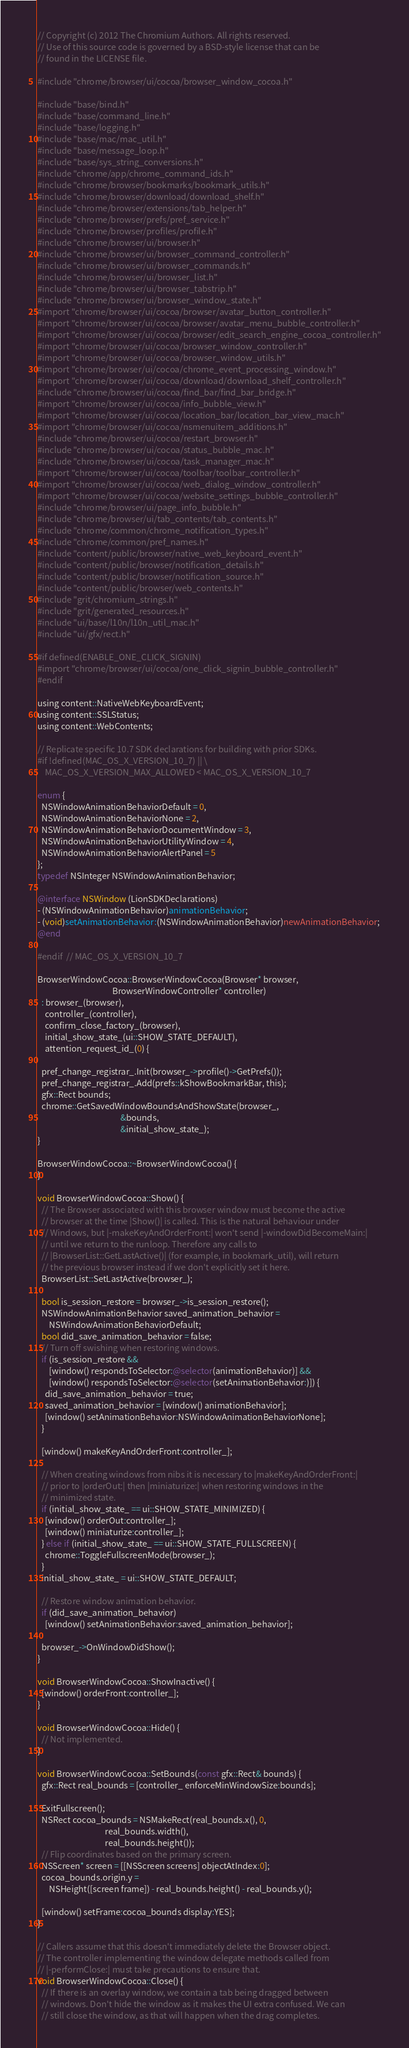Convert code to text. <code><loc_0><loc_0><loc_500><loc_500><_ObjectiveC_>// Copyright (c) 2012 The Chromium Authors. All rights reserved.
// Use of this source code is governed by a BSD-style license that can be
// found in the LICENSE file.

#include "chrome/browser/ui/cocoa/browser_window_cocoa.h"

#include "base/bind.h"
#include "base/command_line.h"
#include "base/logging.h"
#include "base/mac/mac_util.h"
#include "base/message_loop.h"
#include "base/sys_string_conversions.h"
#include "chrome/app/chrome_command_ids.h"
#include "chrome/browser/bookmarks/bookmark_utils.h"
#include "chrome/browser/download/download_shelf.h"
#include "chrome/browser/extensions/tab_helper.h"
#include "chrome/browser/prefs/pref_service.h"
#include "chrome/browser/profiles/profile.h"
#include "chrome/browser/ui/browser.h"
#include "chrome/browser/ui/browser_command_controller.h"
#include "chrome/browser/ui/browser_commands.h"
#include "chrome/browser/ui/browser_list.h"
#include "chrome/browser/ui/browser_tabstrip.h"
#include "chrome/browser/ui/browser_window_state.h"
#import "chrome/browser/ui/cocoa/browser/avatar_button_controller.h"
#import "chrome/browser/ui/cocoa/browser/avatar_menu_bubble_controller.h"
#import "chrome/browser/ui/cocoa/browser/edit_search_engine_cocoa_controller.h"
#import "chrome/browser/ui/cocoa/browser_window_controller.h"
#import "chrome/browser/ui/cocoa/browser_window_utils.h"
#import "chrome/browser/ui/cocoa/chrome_event_processing_window.h"
#import "chrome/browser/ui/cocoa/download/download_shelf_controller.h"
#include "chrome/browser/ui/cocoa/find_bar/find_bar_bridge.h"
#import "chrome/browser/ui/cocoa/info_bubble_view.h"
#import "chrome/browser/ui/cocoa/location_bar/location_bar_view_mac.h"
#import "chrome/browser/ui/cocoa/nsmenuitem_additions.h"
#include "chrome/browser/ui/cocoa/restart_browser.h"
#include "chrome/browser/ui/cocoa/status_bubble_mac.h"
#include "chrome/browser/ui/cocoa/task_manager_mac.h"
#import "chrome/browser/ui/cocoa/toolbar/toolbar_controller.h"
#import "chrome/browser/ui/cocoa/web_dialog_window_controller.h"
#import "chrome/browser/ui/cocoa/website_settings_bubble_controller.h"
#include "chrome/browser/ui/page_info_bubble.h"
#include "chrome/browser/ui/tab_contents/tab_contents.h"
#include "chrome/common/chrome_notification_types.h"
#include "chrome/common/pref_names.h"
#include "content/public/browser/native_web_keyboard_event.h"
#include "content/public/browser/notification_details.h"
#include "content/public/browser/notification_source.h"
#include "content/public/browser/web_contents.h"
#include "grit/chromium_strings.h"
#include "grit/generated_resources.h"
#include "ui/base/l10n/l10n_util_mac.h"
#include "ui/gfx/rect.h"

#if defined(ENABLE_ONE_CLICK_SIGNIN)
#import "chrome/browser/ui/cocoa/one_click_signin_bubble_controller.h"
#endif

using content::NativeWebKeyboardEvent;
using content::SSLStatus;
using content::WebContents;

// Replicate specific 10.7 SDK declarations for building with prior SDKs.
#if !defined(MAC_OS_X_VERSION_10_7) || \
    MAC_OS_X_VERSION_MAX_ALLOWED < MAC_OS_X_VERSION_10_7

enum {
  NSWindowAnimationBehaviorDefault = 0,
  NSWindowAnimationBehaviorNone = 2,
  NSWindowAnimationBehaviorDocumentWindow = 3,
  NSWindowAnimationBehaviorUtilityWindow = 4,
  NSWindowAnimationBehaviorAlertPanel = 5
};
typedef NSInteger NSWindowAnimationBehavior;

@interface NSWindow (LionSDKDeclarations)
- (NSWindowAnimationBehavior)animationBehavior;
- (void)setAnimationBehavior:(NSWindowAnimationBehavior)newAnimationBehavior;
@end

#endif  // MAC_OS_X_VERSION_10_7

BrowserWindowCocoa::BrowserWindowCocoa(Browser* browser,
                                       BrowserWindowController* controller)
  : browser_(browser),
    controller_(controller),
    confirm_close_factory_(browser),
    initial_show_state_(ui::SHOW_STATE_DEFAULT),
    attention_request_id_(0) {

  pref_change_registrar_.Init(browser_->profile()->GetPrefs());
  pref_change_registrar_.Add(prefs::kShowBookmarkBar, this);
  gfx::Rect bounds;
  chrome::GetSavedWindowBoundsAndShowState(browser_,
                                           &bounds,
                                           &initial_show_state_);
}

BrowserWindowCocoa::~BrowserWindowCocoa() {
}

void BrowserWindowCocoa::Show() {
  // The Browser associated with this browser window must become the active
  // browser at the time |Show()| is called. This is the natural behaviour under
  // Windows, but |-makeKeyAndOrderFront:| won't send |-windowDidBecomeMain:|
  // until we return to the runloop. Therefore any calls to
  // |BrowserList::GetLastActive()| (for example, in bookmark_util), will return
  // the previous browser instead if we don't explicitly set it here.
  BrowserList::SetLastActive(browser_);

  bool is_session_restore = browser_->is_session_restore();
  NSWindowAnimationBehavior saved_animation_behavior =
      NSWindowAnimationBehaviorDefault;
  bool did_save_animation_behavior = false;
  // Turn off swishing when restoring windows.
  if (is_session_restore &&
      [window() respondsToSelector:@selector(animationBehavior)] &&
      [window() respondsToSelector:@selector(setAnimationBehavior:)]) {
    did_save_animation_behavior = true;
    saved_animation_behavior = [window() animationBehavior];
    [window() setAnimationBehavior:NSWindowAnimationBehaviorNone];
  }

  [window() makeKeyAndOrderFront:controller_];

  // When creating windows from nibs it is necessary to |makeKeyAndOrderFront:|
  // prior to |orderOut:| then |miniaturize:| when restoring windows in the
  // minimized state.
  if (initial_show_state_ == ui::SHOW_STATE_MINIMIZED) {
    [window() orderOut:controller_];
    [window() miniaturize:controller_];
  } else if (initial_show_state_ == ui::SHOW_STATE_FULLSCREEN) {
    chrome::ToggleFullscreenMode(browser_);
  }
  initial_show_state_ = ui::SHOW_STATE_DEFAULT;

  // Restore window animation behavior.
  if (did_save_animation_behavior)
    [window() setAnimationBehavior:saved_animation_behavior];

  browser_->OnWindowDidShow();
}

void BrowserWindowCocoa::ShowInactive() {
  [window() orderFront:controller_];
}

void BrowserWindowCocoa::Hide() {
  // Not implemented.
}

void BrowserWindowCocoa::SetBounds(const gfx::Rect& bounds) {
  gfx::Rect real_bounds = [controller_ enforceMinWindowSize:bounds];

  ExitFullscreen();
  NSRect cocoa_bounds = NSMakeRect(real_bounds.x(), 0,
                                   real_bounds.width(),
                                   real_bounds.height());
  // Flip coordinates based on the primary screen.
  NSScreen* screen = [[NSScreen screens] objectAtIndex:0];
  cocoa_bounds.origin.y =
      NSHeight([screen frame]) - real_bounds.height() - real_bounds.y();

  [window() setFrame:cocoa_bounds display:YES];
}

// Callers assume that this doesn't immediately delete the Browser object.
// The controller implementing the window delegate methods called from
// |-performClose:| must take precautions to ensure that.
void BrowserWindowCocoa::Close() {
  // If there is an overlay window, we contain a tab being dragged between
  // windows. Don't hide the window as it makes the UI extra confused. We can
  // still close the window, as that will happen when the drag completes.</code> 